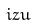Convert formula to latex. <formula><loc_0><loc_0><loc_500><loc_500>i z u</formula> 